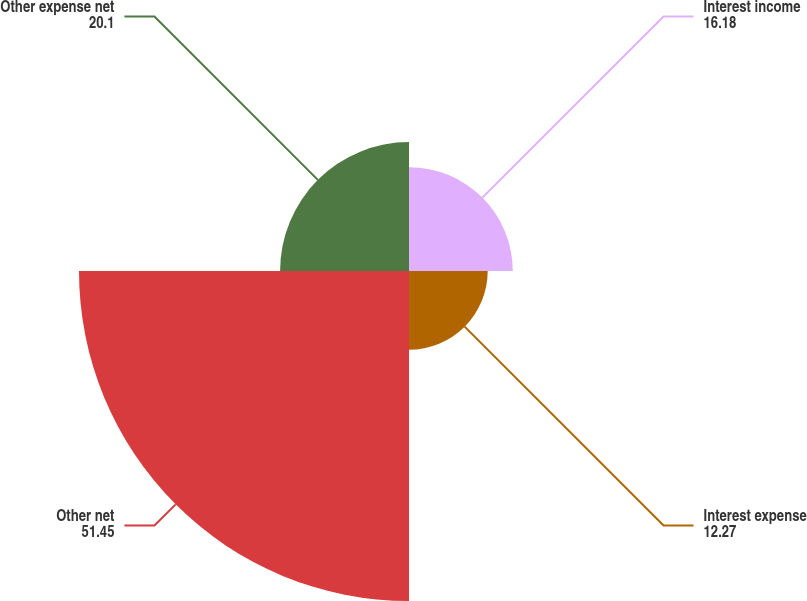Convert chart. <chart><loc_0><loc_0><loc_500><loc_500><pie_chart><fcel>Interest income<fcel>Interest expense<fcel>Other net<fcel>Other expense net<nl><fcel>16.18%<fcel>12.27%<fcel>51.45%<fcel>20.1%<nl></chart> 